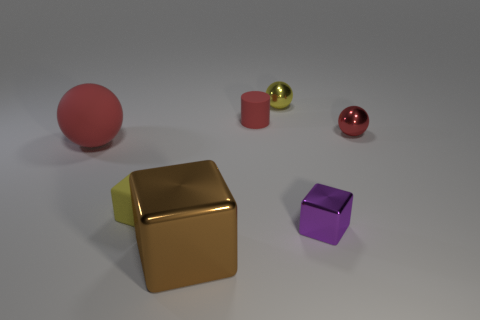Is there anything else that has the same shape as the small red matte thing?
Offer a very short reply. No. There is a red ball that is the same material as the tiny cylinder; what is its size?
Give a very brief answer. Large. There is a large object that is made of the same material as the small red sphere; what is its color?
Make the answer very short. Brown. Is there a purple block of the same size as the yellow ball?
Offer a terse response. Yes. There is a yellow object that is the same shape as the large brown metal object; what is its material?
Offer a very short reply. Rubber. What shape is the purple metallic object that is the same size as the red rubber cylinder?
Make the answer very short. Cube. Is there a large yellow rubber thing that has the same shape as the tiny red metallic thing?
Provide a short and direct response. No. There is a tiny metal thing behind the small red thing on the left side of the tiny yellow metallic object; what shape is it?
Offer a terse response. Sphere. What is the shape of the brown metallic object?
Ensure brevity in your answer.  Cube. There is a tiny yellow block that is left of the red object that is to the right of the tiny yellow object to the right of the small yellow matte cube; what is it made of?
Give a very brief answer. Rubber. 